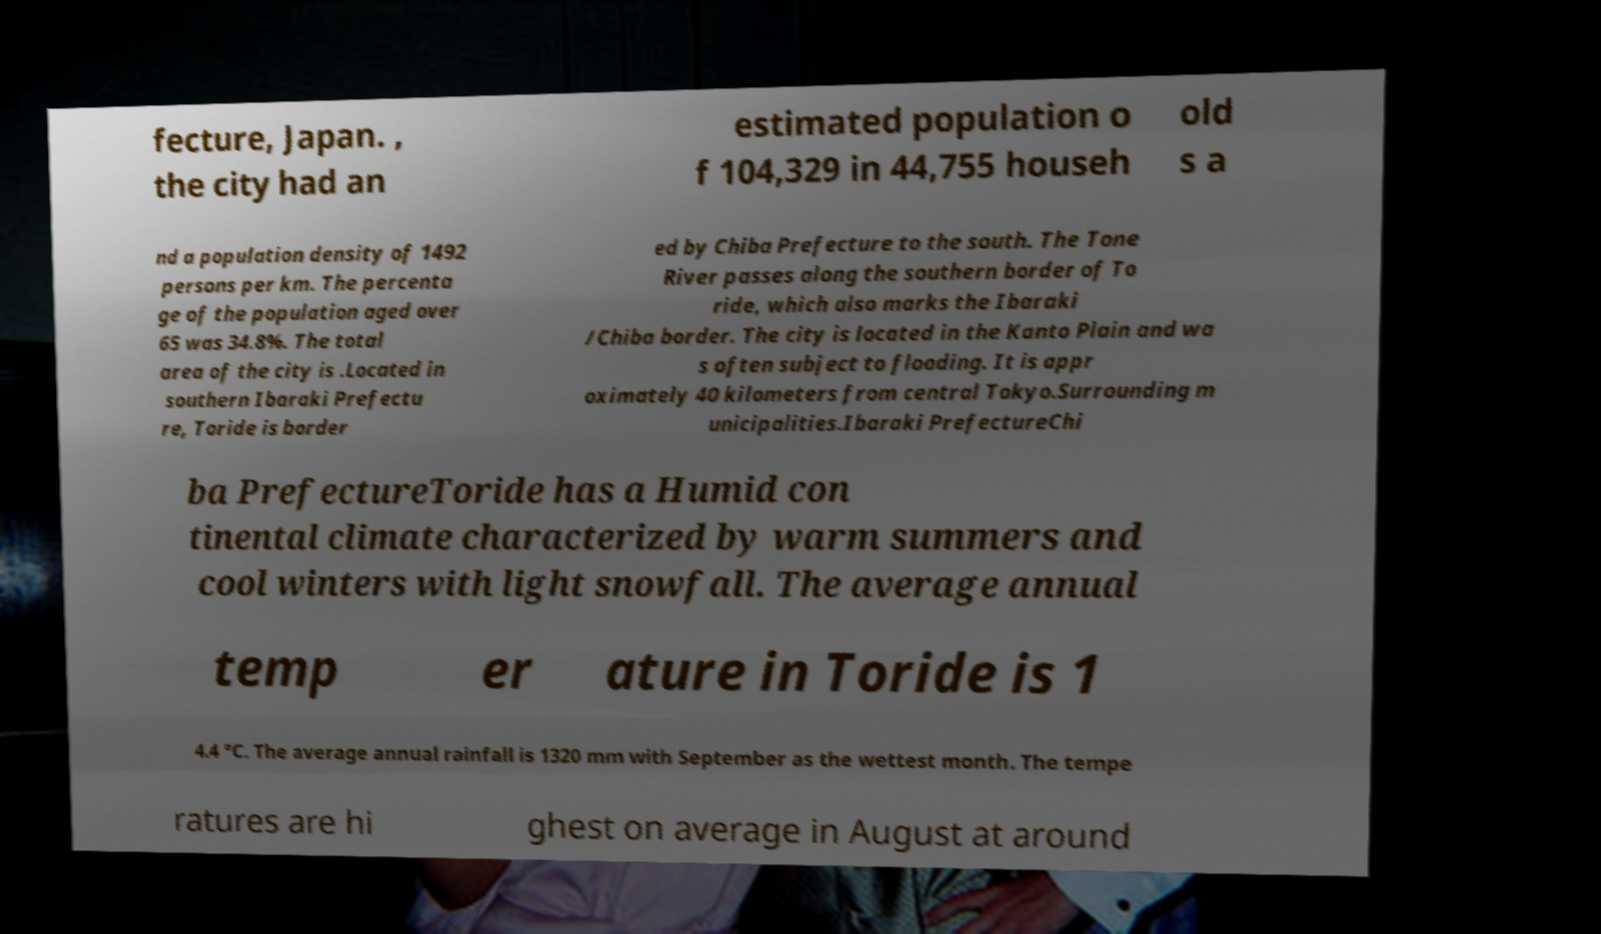Please read and relay the text visible in this image. What does it say? fecture, Japan. , the city had an estimated population o f 104,329 in 44,755 househ old s a nd a population density of 1492 persons per km. The percenta ge of the population aged over 65 was 34.8%. The total area of the city is .Located in southern Ibaraki Prefectu re, Toride is border ed by Chiba Prefecture to the south. The Tone River passes along the southern border of To ride, which also marks the Ibaraki /Chiba border. The city is located in the Kanto Plain and wa s often subject to flooding. It is appr oximately 40 kilometers from central Tokyo.Surrounding m unicipalities.Ibaraki PrefectureChi ba PrefectureToride has a Humid con tinental climate characterized by warm summers and cool winters with light snowfall. The average annual temp er ature in Toride is 1 4.4 °C. The average annual rainfall is 1320 mm with September as the wettest month. The tempe ratures are hi ghest on average in August at around 